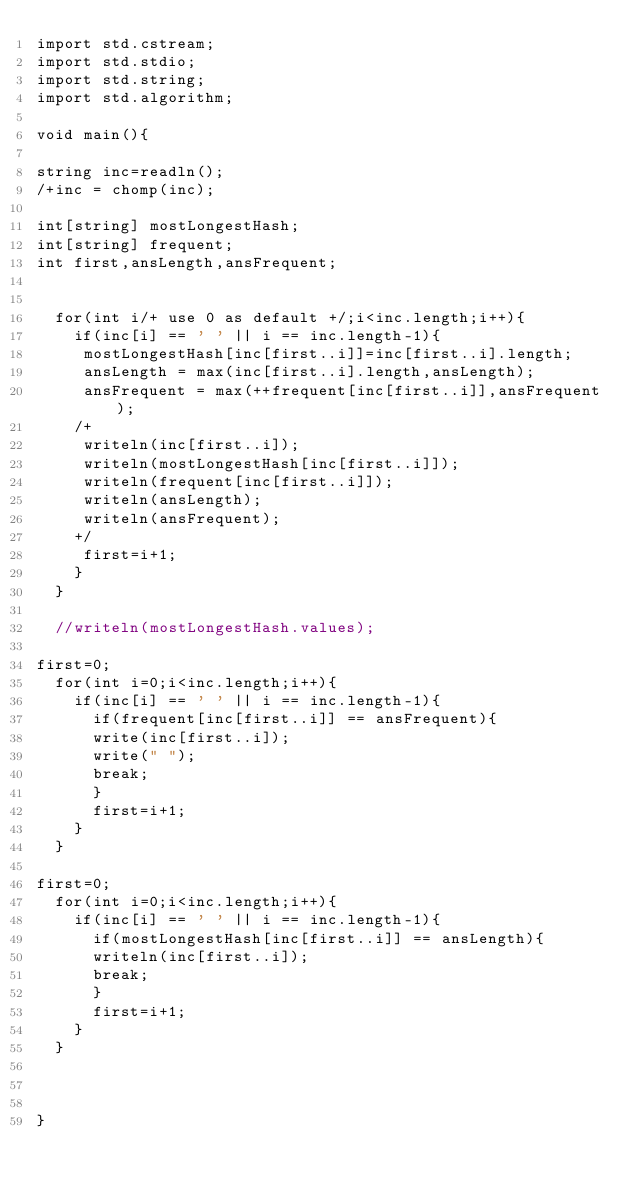<code> <loc_0><loc_0><loc_500><loc_500><_D_>import std.cstream;
import std.stdio;
import std.string;
import std.algorithm;
 
void main(){
 
string inc=readln();
/+inc = chomp(inc);
 
int[string] mostLongestHash;
int[string] frequent;
int first,ansLength,ansFrequent;
 
 
  for(int i/+ use 0 as default +/;i<inc.length;i++){
    if(inc[i] == ' ' || i == inc.length-1){
     mostLongestHash[inc[first..i]]=inc[first..i].length;
     ansLength = max(inc[first..i].length,ansLength);
     ansFrequent = max(++frequent[inc[first..i]],ansFrequent);
    /+
     writeln(inc[first..i]);
     writeln(mostLongestHash[inc[first..i]]);
     writeln(frequent[inc[first..i]]);
     writeln(ansLength);
     writeln(ansFrequent);
    +/
     first=i+1;
    }
  }
 
  //writeln(mostLongestHash.values);
 
first=0;
  for(int i=0;i<inc.length;i++){
    if(inc[i] == ' ' || i == inc.length-1){
      if(frequent[inc[first..i]] == ansFrequent){
      write(inc[first..i]);
      write(" ");
      break;
      }
      first=i+1;
    }
  }
 
first=0;
  for(int i=0;i<inc.length;i++){
    if(inc[i] == ' ' || i == inc.length-1){
      if(mostLongestHash[inc[first..i]] == ansLength){
      writeln(inc[first..i]);
      break;
      }
      first=i+1;
    }
  }
 
 
 
}</code> 